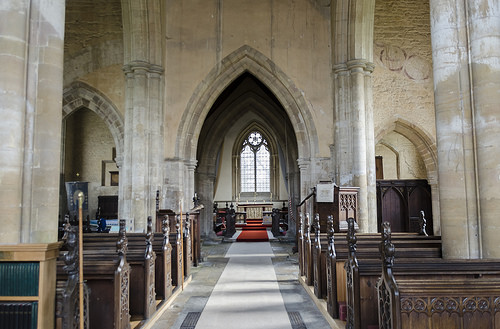<image>
Can you confirm if the column is on the alter? No. The column is not positioned on the alter. They may be near each other, but the column is not supported by or resting on top of the alter. 